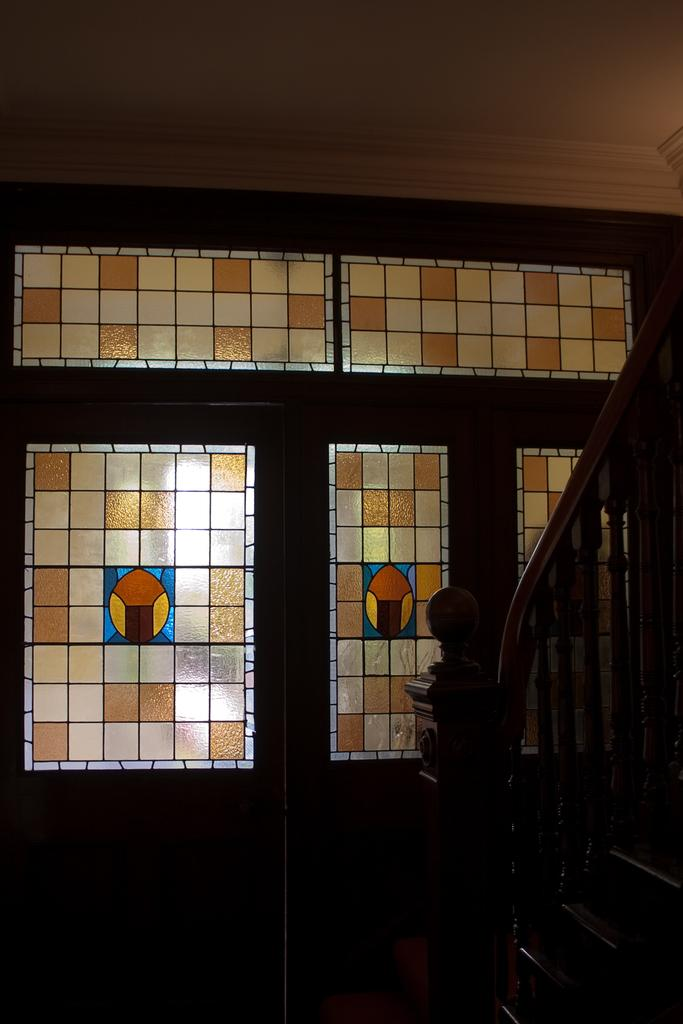What type of glass can be seen in the image? There is stained glass in the image. What architectural feature is present on the right side of the image? There are stairs on the right side of the image. What type of vegetable is being measured on the stairs in the image? There is no vegetable or measuring activity present in the image; it only features stained glass and stairs. 